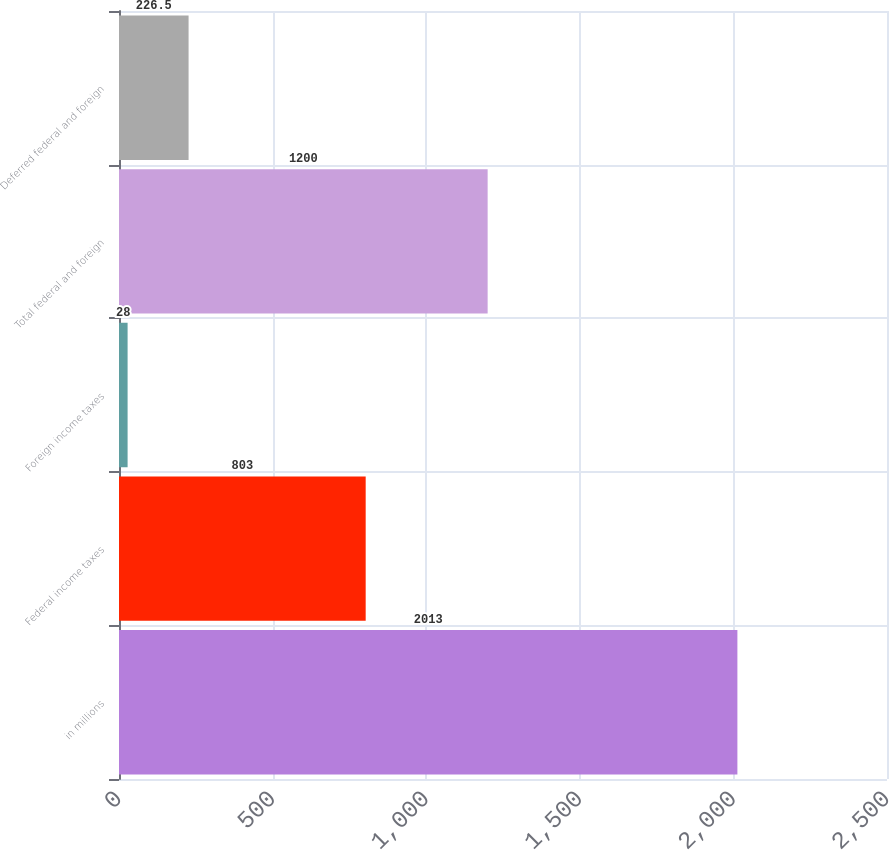Convert chart. <chart><loc_0><loc_0><loc_500><loc_500><bar_chart><fcel>in millions<fcel>Federal income taxes<fcel>Foreign income taxes<fcel>Total federal and foreign<fcel>Deferred federal and foreign<nl><fcel>2013<fcel>803<fcel>28<fcel>1200<fcel>226.5<nl></chart> 